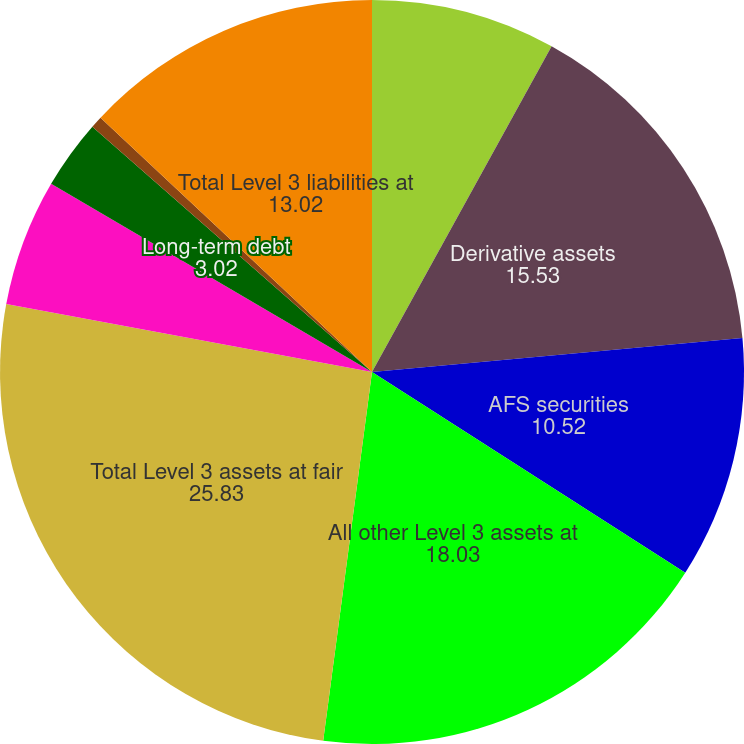Convert chart. <chart><loc_0><loc_0><loc_500><loc_500><pie_chart><fcel>Trading account assets<fcel>Derivative assets<fcel>AFS securities<fcel>All other Level 3 assets at<fcel>Total Level 3 assets at fair<fcel>Derivative liabilities<fcel>Long-term debt<fcel>All other Level 3 liabilities<fcel>Total Level 3 liabilities at<nl><fcel>8.02%<fcel>15.53%<fcel>10.52%<fcel>18.03%<fcel>25.83%<fcel>5.52%<fcel>3.02%<fcel>0.52%<fcel>13.02%<nl></chart> 